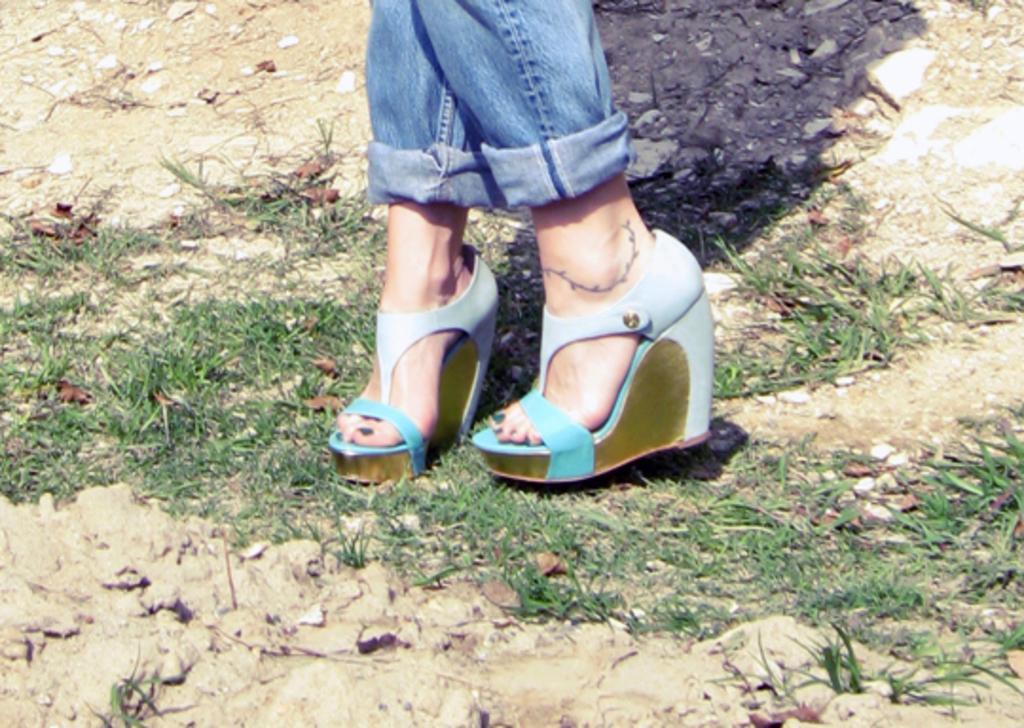Could you give a brief overview of what you see in this image? In the center of the picture there are legs of a woman and there are dry leaves and grass. At the top there are stones. At the bottom there is soil. 